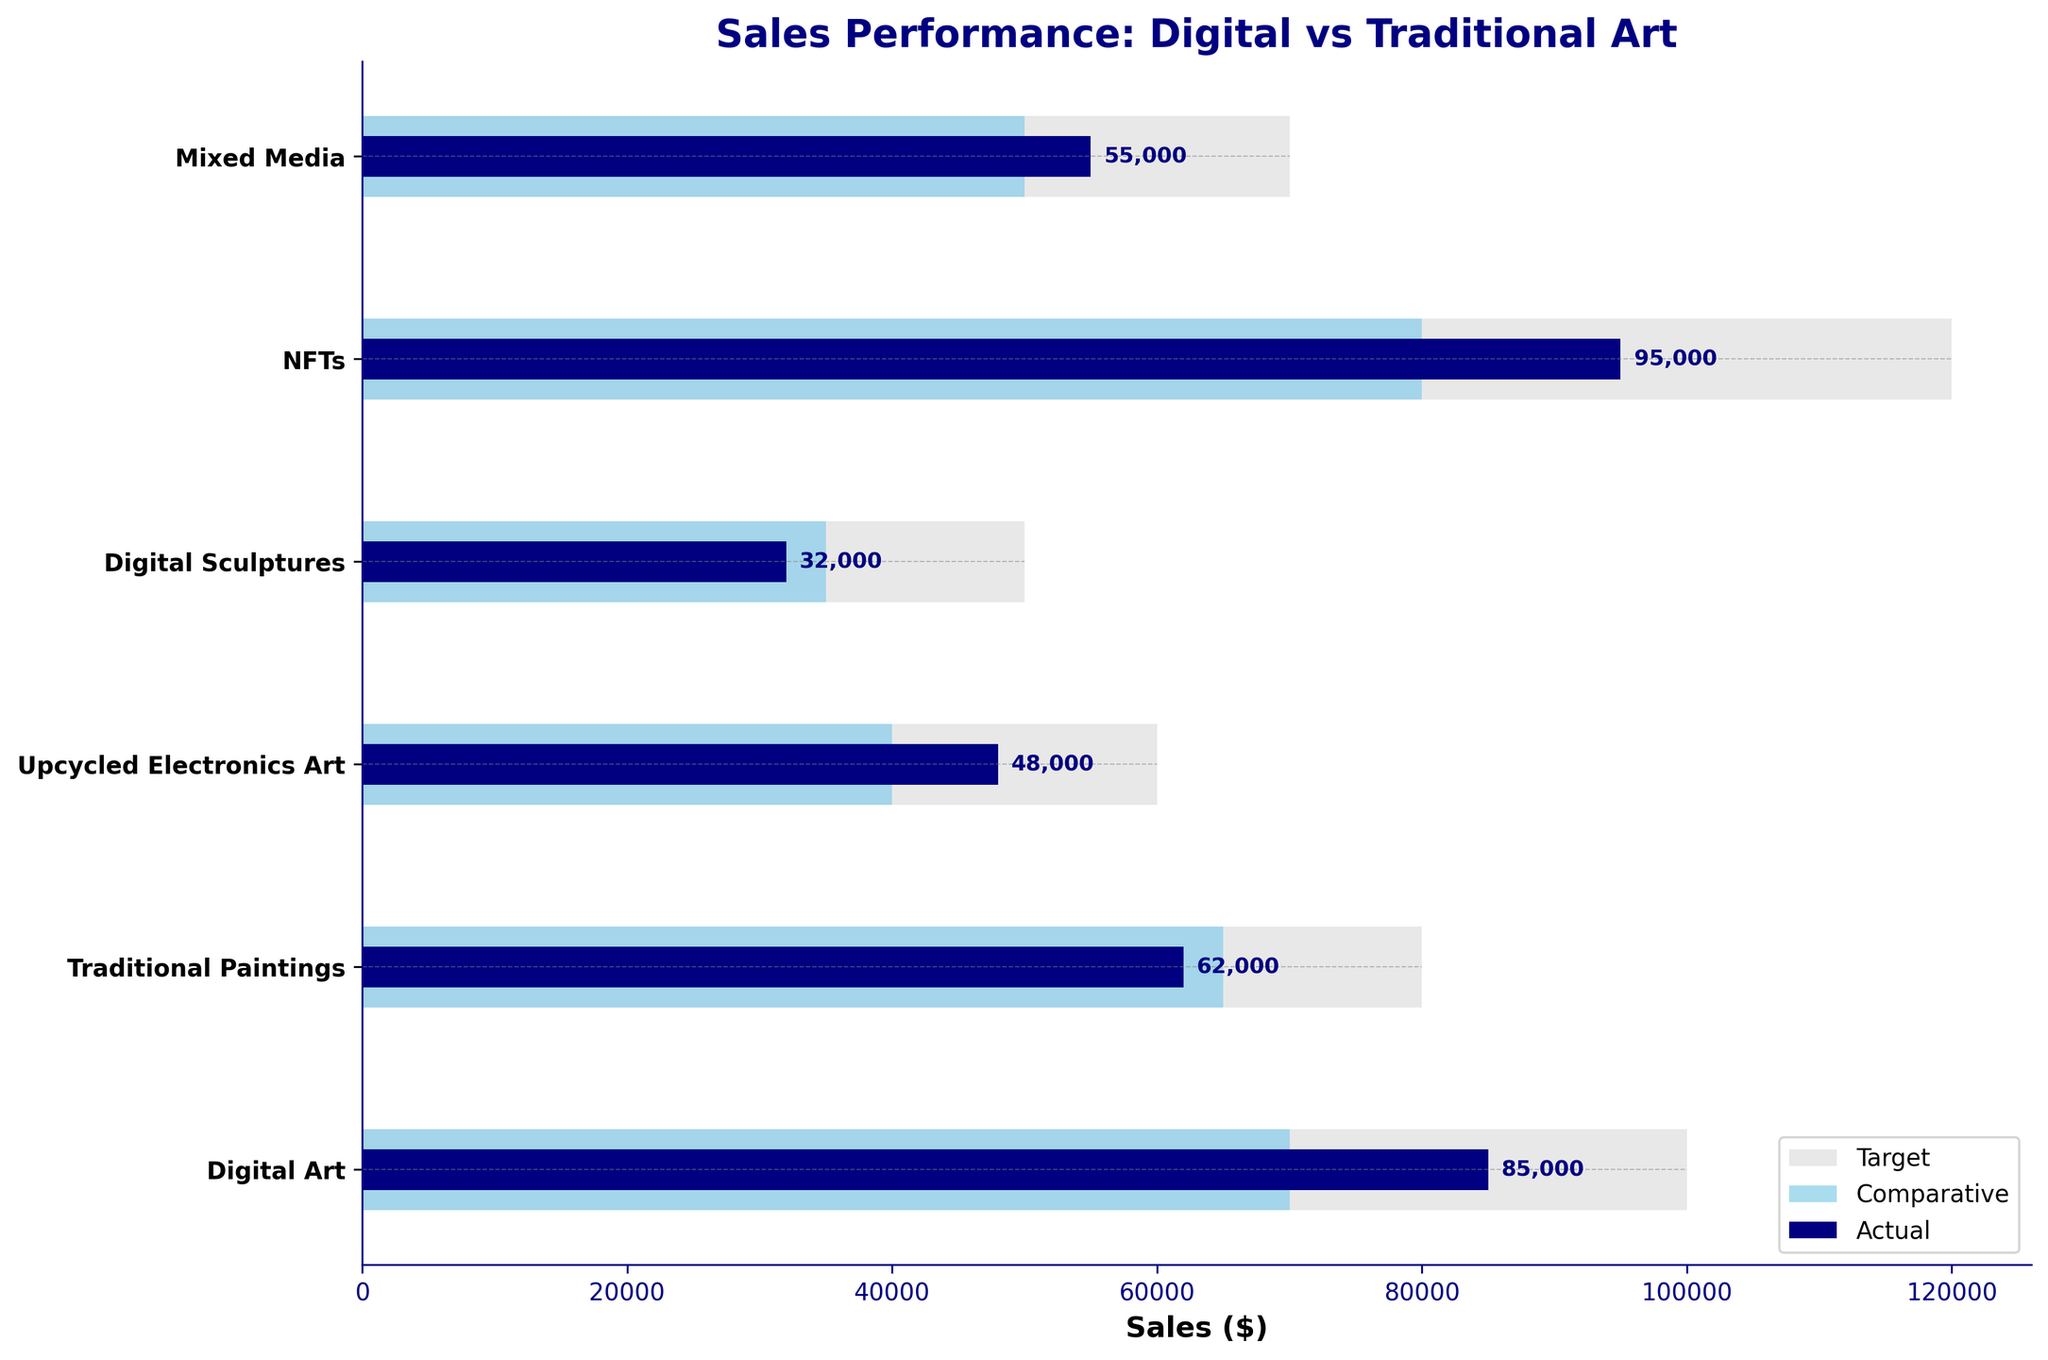What's the title of the figure? The title is placed at the top of the chart; it summarizes the main topic of the figure.
Answer: Sales Performance: Digital vs Traditional Art How many categories are shown in the figure? The number of unique bars on the y-axis corresponds to the number of categories. Counting them gives us 6 categories.
Answer: 6 What is the sales target for NFTs? The target value for each category is represented by the longest light gray bar. For NFTs, it's found at the end of the respective light gray bar.
Answer: $120,000 Which category has the highest actual sales? By comparing the length of the navy blue bars (representing actual sales) for all categories, the longest bar corresponds to the highest actual sales. This is for NFTs.
Answer: NFTs What is the difference between the actual and target sales for Upcycled Electronics Art? For Upcycled Electronics Art, the actual sales (navy bar) is $48,000 and the target sales (gray bar) is $60,000. Subtracting actual from target gives us $60,000 - $48,000.
Answer: $12,000 How do the actual sales of Digital Art compare to the comparative sales of Traditional Paintings? The actual sales for Digital Art (navy bar) are $85,000, and the comparative sales for Traditional Paintings (sky blue bar) are $65,000. Digital Art's actual sales are higher by $85,000 - $65,000.
Answer: $20,000 higher Which category has actual sales closest to its comparative sales? Compare the lengths of the navy and sky blue bars for each category. The smallest difference between these bars will be the answer. Upcycled Electronics Art has actual sales of $48,000 and comparative sales of $40,000, closest with a difference of $8,000.
Answer: Upcycled Electronics Art Are there any categories where the actual sales exceed the target sales? The actual sales exceed the target sales if the navy bar is longer than the light gray bar. Reviewing each category, none of the actual sales bars exceed their target bars.
Answer: No What percentage of the target sales was achieved by Digital Sculptures? Actual sales for Digital Sculptures are $32,000, and the target sales are $50,000. The percentage is calculated by (32,000 / 50,000) * 100%.
Answer: 64% Which category has the smallest difference between actual and target sales, and what is it? The smallest difference can be found by calculating the absolute difference between actual and target sales for each category. Digital Art has actual sales of $85,000 and a target of $100,000, which gives a difference of $15,000. This is the smallest among all categories.
Answer: Digital Art, $15,000 